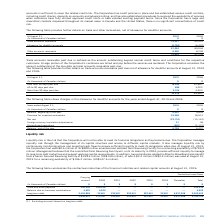According to Cogeco's financial document, What is the basis for the doubtful accounts receivable calculation? Based on the financial document, the answer is The doubtful accounts allowance is calculated on a specific-identification basis for larger customer accounts receivable and on a statistically derived basis for the remainder.. Also, What was the other accounts receivable in 2019? According to the financial document, 8,390 (in thousands). The relevant text states: "Other accounts receivable 8,390 8,250..." Also, What is the trade accounts receivable in 2019? According to the financial document, 74,021 (in thousands). The relevant text states: "Trade accounts receivable 74,021 95,541..." Also, can you calculate: What is the increase / (decrease) in the trade accounts receivable from 2018 to 2019? Based on the calculation: 74,021 - 95,541, the result is -21520 (in thousands). This is based on the information: "Trade accounts receivable 74,021 95,541 Trade accounts receivable 74,021 95,541..." The key data points involved are: 74,021, 95,541. Also, can you calculate: What was the average allowance for doubtful accounts from 2018 to 2019? To answer this question, I need to perform calculations using the financial data. The calculation is: -(6,759 + 6,497) / 2, which equals -6628 (in thousands). This is based on the information: "Allowance for doubtful accounts (6,759) (6,497) Allowance for doubtful accounts (6,759) (6,497)..." The key data points involved are: 6,497, 6,759. Also, can you calculate: What is the average other accounts receivable from 2018 to 2019? To answer this question, I need to perform calculations using the financial data. The calculation is: (8,390 + 8,250) / 2, which equals 8320 (in thousands). This is based on the information: "Other accounts receivable 8,390 8,250 Other accounts receivable 8,390 8,250..." The key data points involved are: 8,250, 8,390. 